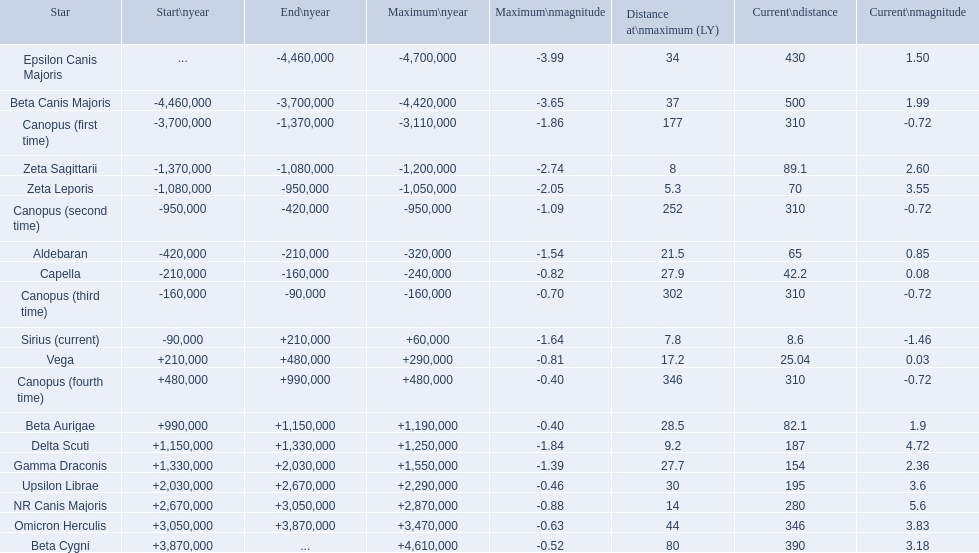Which star possesses a maximum magnitude of -0.63? Omicron Herculis. Additionally, which star is presently 390 units away? Beta Cygni. 